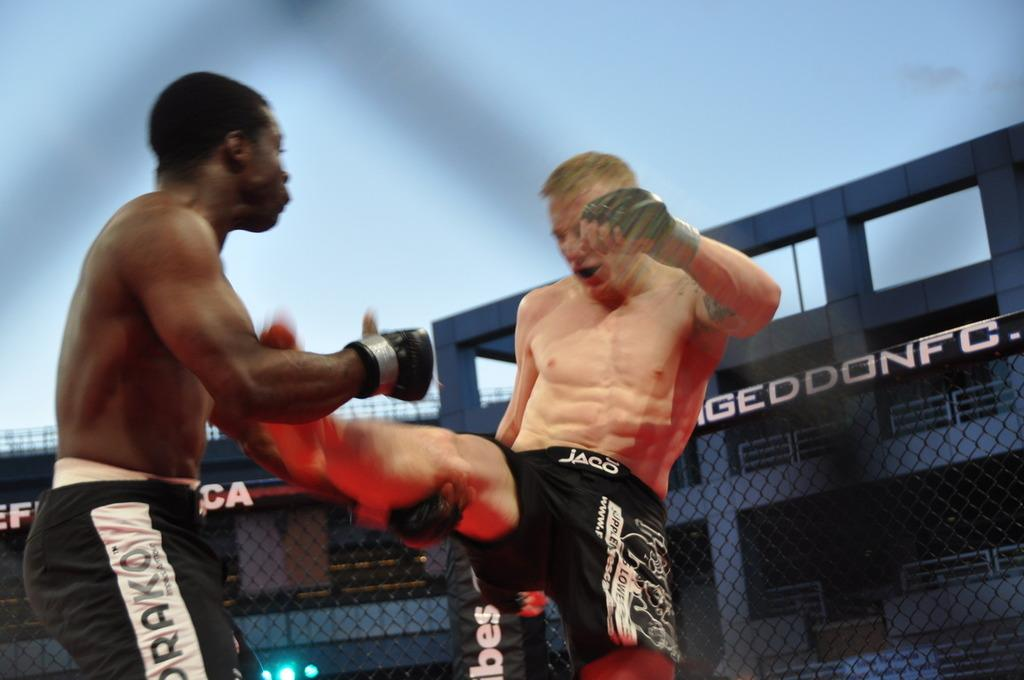<image>
Describe the image concisely. Two wrestlers fight in front of a sign that says GEDDONFC 